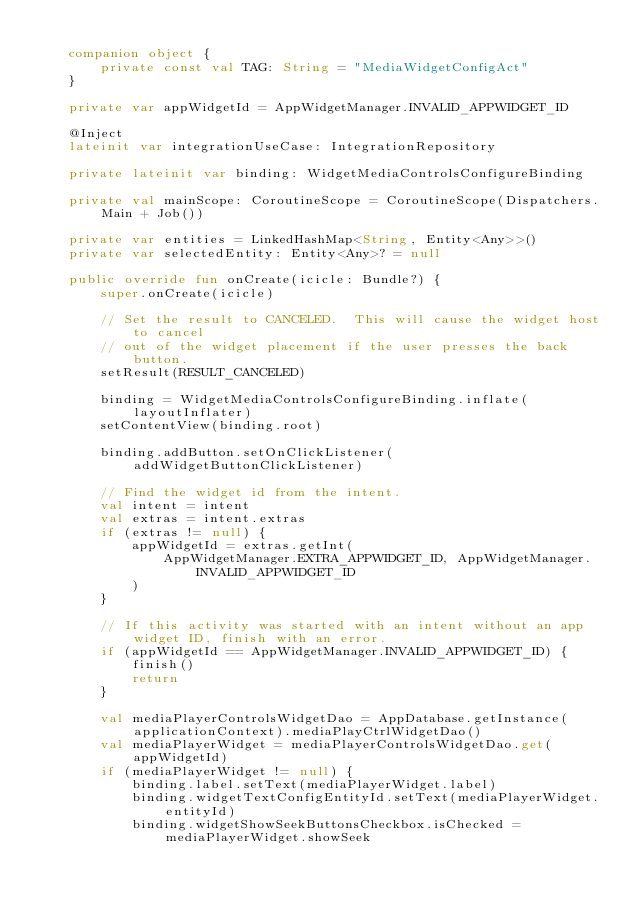Convert code to text. <code><loc_0><loc_0><loc_500><loc_500><_Kotlin_>
    companion object {
        private const val TAG: String = "MediaWidgetConfigAct"
    }

    private var appWidgetId = AppWidgetManager.INVALID_APPWIDGET_ID

    @Inject
    lateinit var integrationUseCase: IntegrationRepository

    private lateinit var binding: WidgetMediaControlsConfigureBinding

    private val mainScope: CoroutineScope = CoroutineScope(Dispatchers.Main + Job())

    private var entities = LinkedHashMap<String, Entity<Any>>()
    private var selectedEntity: Entity<Any>? = null

    public override fun onCreate(icicle: Bundle?) {
        super.onCreate(icicle)

        // Set the result to CANCELED.  This will cause the widget host to cancel
        // out of the widget placement if the user presses the back button.
        setResult(RESULT_CANCELED)

        binding = WidgetMediaControlsConfigureBinding.inflate(layoutInflater)
        setContentView(binding.root)

        binding.addButton.setOnClickListener(addWidgetButtonClickListener)

        // Find the widget id from the intent.
        val intent = intent
        val extras = intent.extras
        if (extras != null) {
            appWidgetId = extras.getInt(
                AppWidgetManager.EXTRA_APPWIDGET_ID, AppWidgetManager.INVALID_APPWIDGET_ID
            )
        }

        // If this activity was started with an intent without an app widget ID, finish with an error.
        if (appWidgetId == AppWidgetManager.INVALID_APPWIDGET_ID) {
            finish()
            return
        }

        val mediaPlayerControlsWidgetDao = AppDatabase.getInstance(applicationContext).mediaPlayCtrlWidgetDao()
        val mediaPlayerWidget = mediaPlayerControlsWidgetDao.get(appWidgetId)
        if (mediaPlayerWidget != null) {
            binding.label.setText(mediaPlayerWidget.label)
            binding.widgetTextConfigEntityId.setText(mediaPlayerWidget.entityId)
            binding.widgetShowSeekButtonsCheckbox.isChecked = mediaPlayerWidget.showSeek</code> 